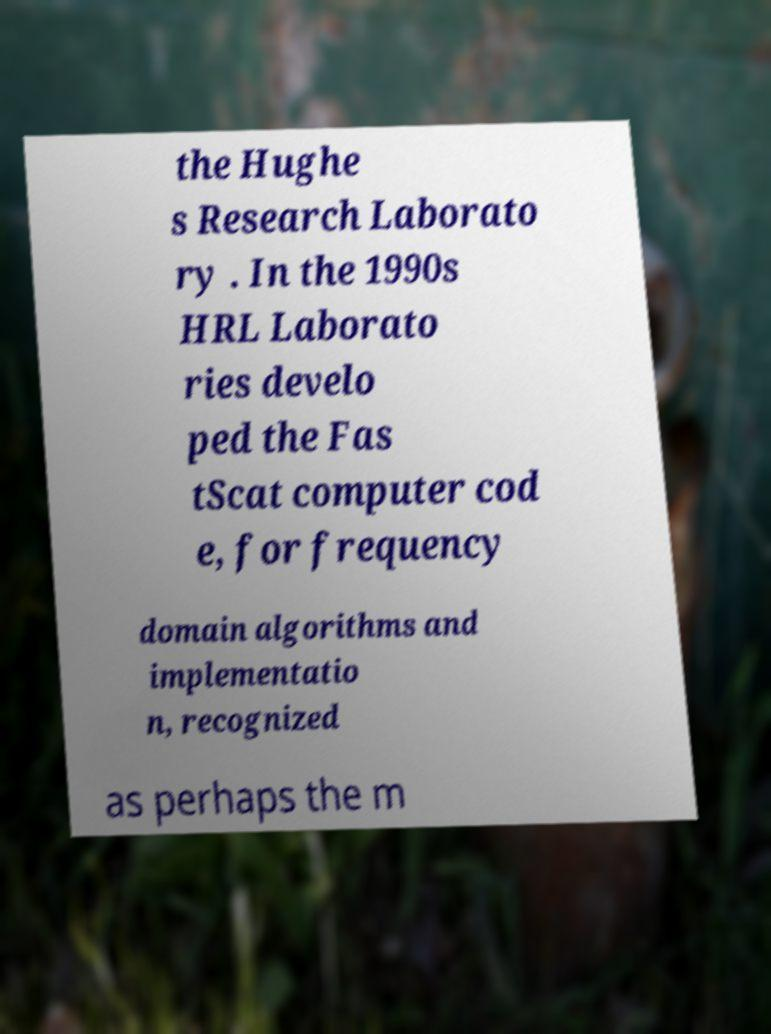Could you assist in decoding the text presented in this image and type it out clearly? the Hughe s Research Laborato ry . In the 1990s HRL Laborato ries develo ped the Fas tScat computer cod e, for frequency domain algorithms and implementatio n, recognized as perhaps the m 